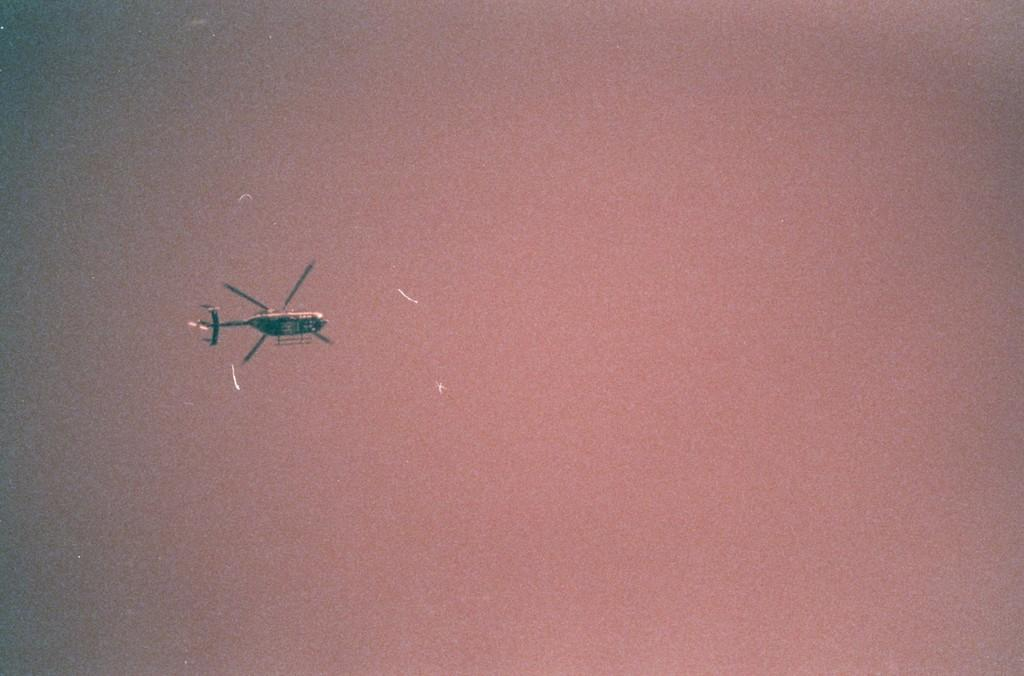What is the main subject of the image? The main subject of the image is an aircraft. Can you describe the sky in the background of the image? The sky in the background of the image is gray and light pink in color. What degree does the chicken have in the image? There is no chicken present in the image, so it cannot have a degree. 